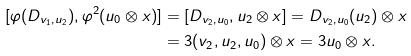<formula> <loc_0><loc_0><loc_500><loc_500>[ \varphi ( D _ { v _ { 1 } , u _ { 2 } } ) , \varphi ^ { 2 } ( u _ { 0 } \otimes x ) ] & = [ D _ { v _ { 2 } , u _ { 0 } } , u _ { 2 } \otimes x ] = D _ { v _ { 2 } , u _ { 0 } } ( u _ { 2 } ) \otimes x \\ & = 3 ( v _ { 2 } , u _ { 2 } , u _ { 0 } ) \otimes x = 3 u _ { 0 } \otimes x .</formula> 